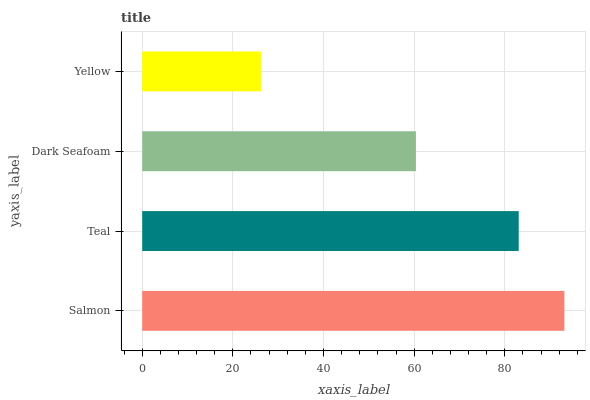Is Yellow the minimum?
Answer yes or no. Yes. Is Salmon the maximum?
Answer yes or no. Yes. Is Teal the minimum?
Answer yes or no. No. Is Teal the maximum?
Answer yes or no. No. Is Salmon greater than Teal?
Answer yes or no. Yes. Is Teal less than Salmon?
Answer yes or no. Yes. Is Teal greater than Salmon?
Answer yes or no. No. Is Salmon less than Teal?
Answer yes or no. No. Is Teal the high median?
Answer yes or no. Yes. Is Dark Seafoam the low median?
Answer yes or no. Yes. Is Dark Seafoam the high median?
Answer yes or no. No. Is Salmon the low median?
Answer yes or no. No. 